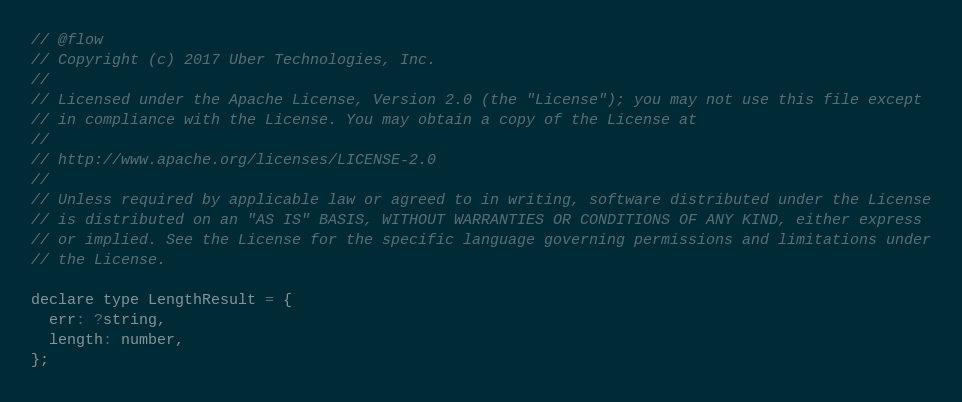Convert code to text. <code><loc_0><loc_0><loc_500><loc_500><_JavaScript_>// @flow
// Copyright (c) 2017 Uber Technologies, Inc.
//
// Licensed under the Apache License, Version 2.0 (the "License"); you may not use this file except
// in compliance with the License. You may obtain a copy of the License at
//
// http://www.apache.org/licenses/LICENSE-2.0
//
// Unless required by applicable law or agreed to in writing, software distributed under the License
// is distributed on an "AS IS" BASIS, WITHOUT WARRANTIES OR CONDITIONS OF ANY KIND, either express
// or implied. See the License for the specific language governing permissions and limitations under
// the License.

declare type LengthResult = {
  err: ?string,
  length: number,
};
</code> 